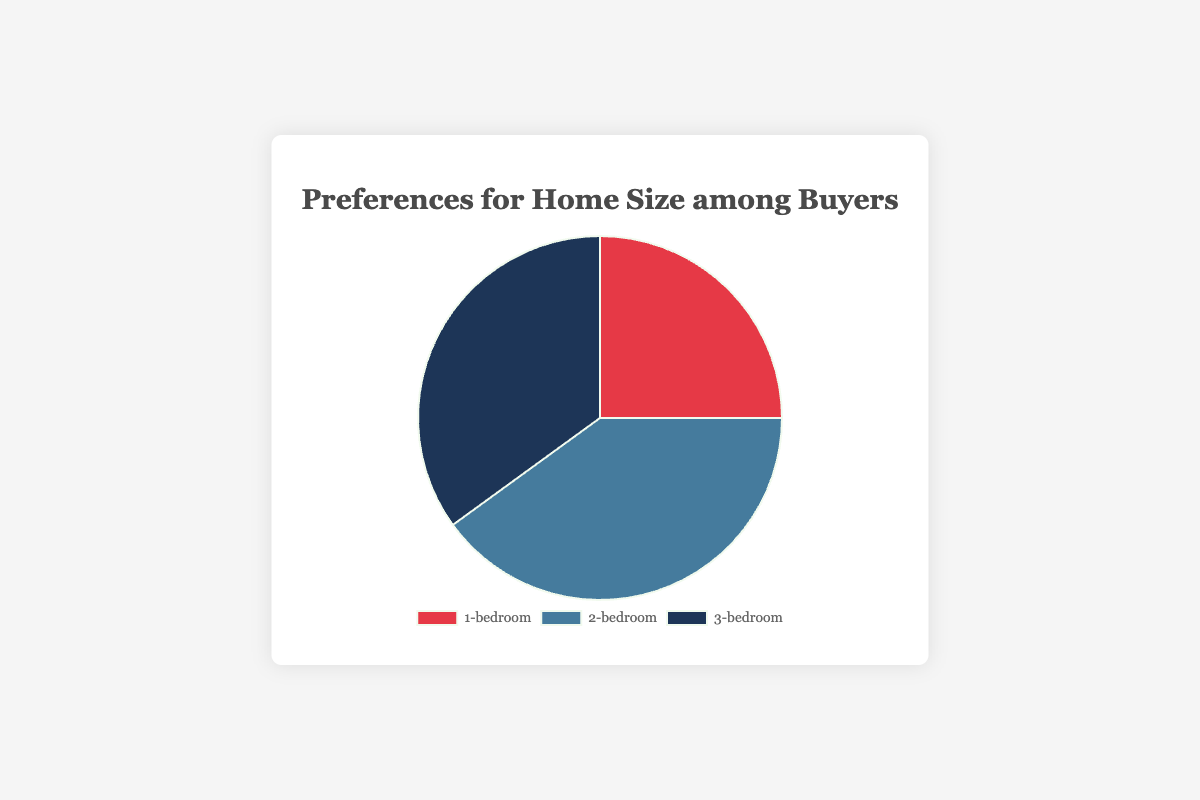What's the most preferred home size among buyers? The largest segment in the pie chart represents the 2-bedroom preference with 40%. This is the highest percentage among the given types.
Answer: 2-bedroom How many percentage points more do buyers prefer 2-bedroom homes over 3-bedroom homes? The preference for 2-bedroom homes is 40% and for 3-bedroom homes is 35%. Subtract 35 from 40: 40% - 35% = 5%.
Answer: 5% What is the combined percentage for 1-bedroom and 2-bedroom preferences? The preference for 1-bedroom homes is 25% and for 2-bedroom homes is 40%. Add these two: 25% + 40% = 65%.
Answer: 65% Which home size is represented by the smallest segment in the pie chart? The smallest segment in the pie chart corresponds to the 1-bedroom preference, which is 25%.
Answer: 1-bedroom By what factor is the preference for 2-bedroom homes larger than the preference for 1-bedroom homes? The preference for 2-bedroom homes is 40% and for 1-bedroom homes is 25%. Divide 40 by 25: 40 / 25 = 1.6.
Answer: 1.6 What percentage of buyers prefer homes that have more than one bedroom? Add the percentages for 2-bedroom and 3-bedroom preferences: 40% + 35% = 75%.
Answer: 75% What color represents the preference for 3-bedroom homes in the chart? The 3-bedroom preference is shown in a dark blue color in the chart.
Answer: Dark blue What proportion of the pie chart does the 1-bedroom home preference occupy? The 1-bedroom home preference occupies 25% of the entire pie chart since each percentage point represents an equal part of the 100% total.
Answer: 25% How much smaller in percentage points is the 3-bedroom preference compared to the combined 1-bedroom and 2-bedroom preferences? The combined percentage for 1-bedroom and 2-bedroom homes is 65% (25% + 40%), and the 3-bedroom preference is 35%. Subtract 35 from 65: 65% - 35% = 30%.
Answer: 30% 